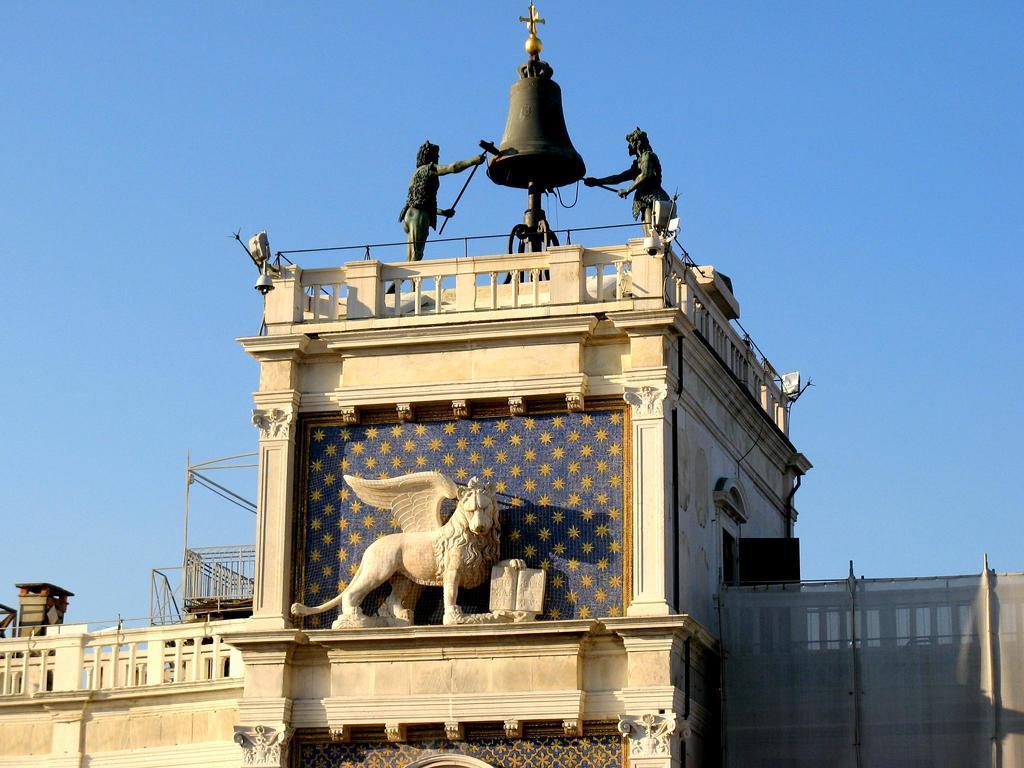Could you give a brief overview of what you see in this image? In this picture I can observe a building. In the middle of the picture I can observe statue of a lion with wings. On the top of the building I can observe two statues of humans. In the background there is sky. 